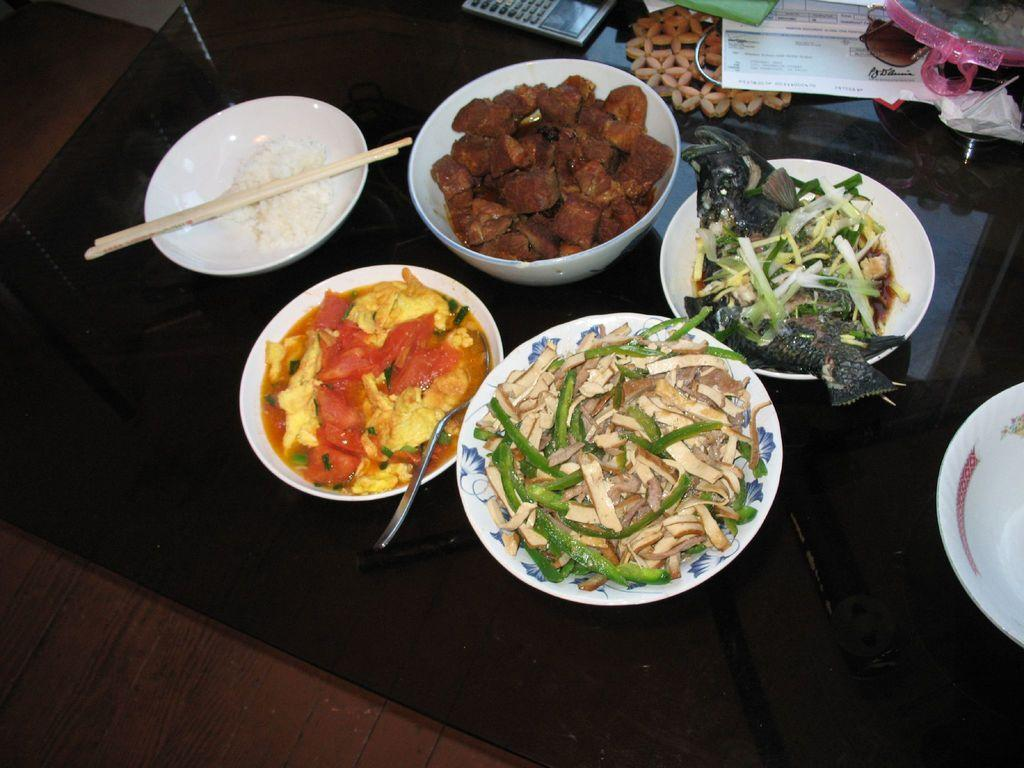What is present in the picture? There is a table in the picture. What is on the table? There is food served on the table. How is the food arranged on the table? The food is in different types of bowls. What can be seen in the front of the table? There are objects placed in the front of the table. What type of rifle is placed on the table in the image? There is no rifle present in the image; it only features a table with food and objects. 